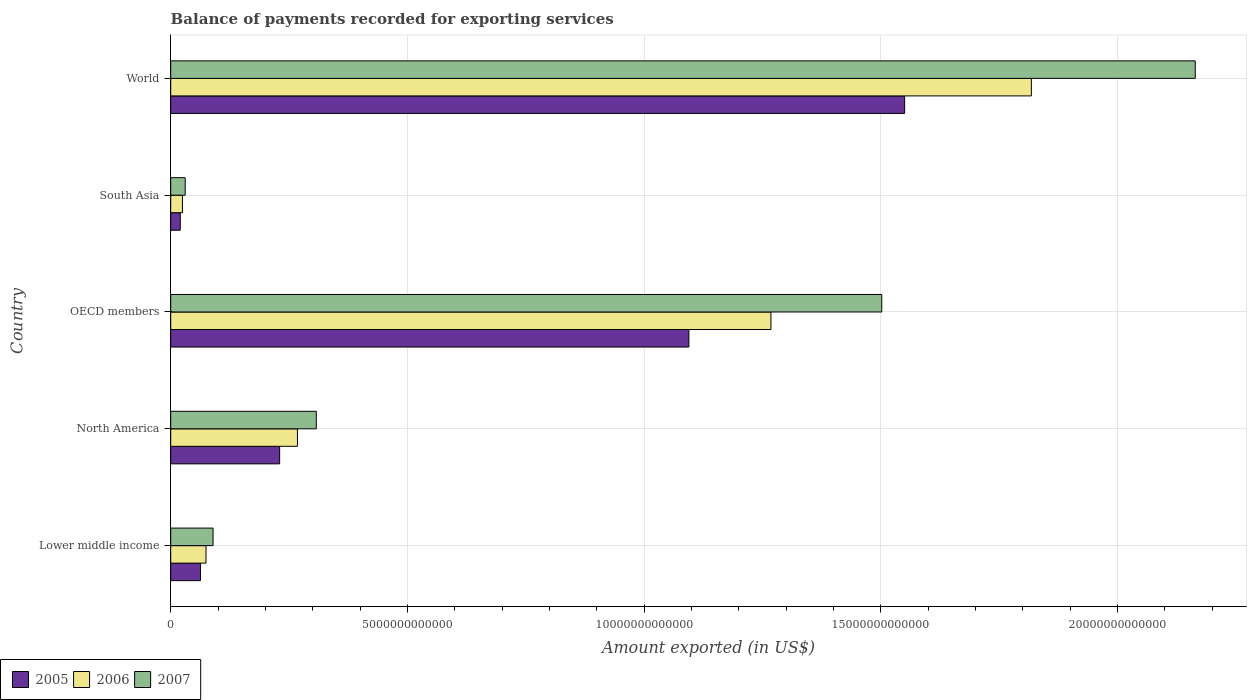Are the number of bars on each tick of the Y-axis equal?
Keep it short and to the point. Yes. How many bars are there on the 1st tick from the bottom?
Offer a very short reply. 3. What is the label of the 5th group of bars from the top?
Provide a succinct answer. Lower middle income. What is the amount exported in 2005 in North America?
Your answer should be very brief. 2.30e+12. Across all countries, what is the maximum amount exported in 2007?
Keep it short and to the point. 2.16e+13. Across all countries, what is the minimum amount exported in 2007?
Your answer should be compact. 3.06e+11. What is the total amount exported in 2006 in the graph?
Offer a terse response. 3.45e+13. What is the difference between the amount exported in 2005 in OECD members and that in South Asia?
Your answer should be compact. 1.07e+13. What is the difference between the amount exported in 2006 in Lower middle income and the amount exported in 2005 in South Asia?
Your response must be concise. 5.44e+11. What is the average amount exported in 2006 per country?
Keep it short and to the point. 6.91e+12. What is the difference between the amount exported in 2005 and amount exported in 2006 in OECD members?
Offer a very short reply. -1.73e+12. What is the ratio of the amount exported in 2006 in North America to that in World?
Your response must be concise. 0.15. Is the difference between the amount exported in 2005 in North America and OECD members greater than the difference between the amount exported in 2006 in North America and OECD members?
Provide a succinct answer. Yes. What is the difference between the highest and the second highest amount exported in 2007?
Offer a terse response. 6.62e+12. What is the difference between the highest and the lowest amount exported in 2005?
Give a very brief answer. 1.53e+13. Is the sum of the amount exported in 2005 in OECD members and World greater than the maximum amount exported in 2007 across all countries?
Ensure brevity in your answer.  Yes. What does the 2nd bar from the top in World represents?
Provide a succinct answer. 2006. What does the 2nd bar from the bottom in South Asia represents?
Keep it short and to the point. 2006. Is it the case that in every country, the sum of the amount exported in 2005 and amount exported in 2006 is greater than the amount exported in 2007?
Give a very brief answer. Yes. How many bars are there?
Provide a succinct answer. 15. Are all the bars in the graph horizontal?
Your answer should be compact. Yes. How many countries are there in the graph?
Provide a succinct answer. 5. What is the difference between two consecutive major ticks on the X-axis?
Provide a succinct answer. 5.00e+12. Are the values on the major ticks of X-axis written in scientific E-notation?
Provide a short and direct response. No. Does the graph contain grids?
Your answer should be very brief. Yes. What is the title of the graph?
Provide a short and direct response. Balance of payments recorded for exporting services. What is the label or title of the X-axis?
Your answer should be very brief. Amount exported (in US$). What is the label or title of the Y-axis?
Give a very brief answer. Country. What is the Amount exported (in US$) of 2005 in Lower middle income?
Provide a short and direct response. 6.29e+11. What is the Amount exported (in US$) in 2006 in Lower middle income?
Give a very brief answer. 7.46e+11. What is the Amount exported (in US$) of 2007 in Lower middle income?
Keep it short and to the point. 8.95e+11. What is the Amount exported (in US$) in 2005 in North America?
Make the answer very short. 2.30e+12. What is the Amount exported (in US$) of 2006 in North America?
Provide a succinct answer. 2.68e+12. What is the Amount exported (in US$) in 2007 in North America?
Provide a short and direct response. 3.08e+12. What is the Amount exported (in US$) of 2005 in OECD members?
Keep it short and to the point. 1.09e+13. What is the Amount exported (in US$) of 2006 in OECD members?
Your response must be concise. 1.27e+13. What is the Amount exported (in US$) in 2007 in OECD members?
Make the answer very short. 1.50e+13. What is the Amount exported (in US$) in 2005 in South Asia?
Give a very brief answer. 2.02e+11. What is the Amount exported (in US$) in 2006 in South Asia?
Offer a terse response. 2.48e+11. What is the Amount exported (in US$) in 2007 in South Asia?
Give a very brief answer. 3.06e+11. What is the Amount exported (in US$) in 2005 in World?
Give a very brief answer. 1.55e+13. What is the Amount exported (in US$) of 2006 in World?
Provide a succinct answer. 1.82e+13. What is the Amount exported (in US$) in 2007 in World?
Ensure brevity in your answer.  2.16e+13. Across all countries, what is the maximum Amount exported (in US$) in 2005?
Provide a short and direct response. 1.55e+13. Across all countries, what is the maximum Amount exported (in US$) in 2006?
Your answer should be compact. 1.82e+13. Across all countries, what is the maximum Amount exported (in US$) in 2007?
Ensure brevity in your answer.  2.16e+13. Across all countries, what is the minimum Amount exported (in US$) of 2005?
Your response must be concise. 2.02e+11. Across all countries, what is the minimum Amount exported (in US$) in 2006?
Your response must be concise. 2.48e+11. Across all countries, what is the minimum Amount exported (in US$) in 2007?
Provide a short and direct response. 3.06e+11. What is the total Amount exported (in US$) of 2005 in the graph?
Provide a short and direct response. 2.96e+13. What is the total Amount exported (in US$) in 2006 in the graph?
Provide a succinct answer. 3.45e+13. What is the total Amount exported (in US$) of 2007 in the graph?
Ensure brevity in your answer.  4.09e+13. What is the difference between the Amount exported (in US$) of 2005 in Lower middle income and that in North America?
Provide a succinct answer. -1.67e+12. What is the difference between the Amount exported (in US$) in 2006 in Lower middle income and that in North America?
Offer a terse response. -1.93e+12. What is the difference between the Amount exported (in US$) in 2007 in Lower middle income and that in North America?
Your answer should be very brief. -2.18e+12. What is the difference between the Amount exported (in US$) in 2005 in Lower middle income and that in OECD members?
Offer a terse response. -1.03e+13. What is the difference between the Amount exported (in US$) in 2006 in Lower middle income and that in OECD members?
Provide a short and direct response. -1.19e+13. What is the difference between the Amount exported (in US$) in 2007 in Lower middle income and that in OECD members?
Your answer should be compact. -1.41e+13. What is the difference between the Amount exported (in US$) in 2005 in Lower middle income and that in South Asia?
Give a very brief answer. 4.27e+11. What is the difference between the Amount exported (in US$) of 2006 in Lower middle income and that in South Asia?
Provide a succinct answer. 4.98e+11. What is the difference between the Amount exported (in US$) in 2007 in Lower middle income and that in South Asia?
Your answer should be very brief. 5.89e+11. What is the difference between the Amount exported (in US$) in 2005 in Lower middle income and that in World?
Offer a terse response. -1.49e+13. What is the difference between the Amount exported (in US$) in 2006 in Lower middle income and that in World?
Ensure brevity in your answer.  -1.74e+13. What is the difference between the Amount exported (in US$) in 2007 in Lower middle income and that in World?
Keep it short and to the point. -2.08e+13. What is the difference between the Amount exported (in US$) in 2005 in North America and that in OECD members?
Provide a succinct answer. -8.65e+12. What is the difference between the Amount exported (in US$) in 2006 in North America and that in OECD members?
Give a very brief answer. -1.00e+13. What is the difference between the Amount exported (in US$) of 2007 in North America and that in OECD members?
Offer a very short reply. -1.19e+13. What is the difference between the Amount exported (in US$) in 2005 in North America and that in South Asia?
Your answer should be very brief. 2.10e+12. What is the difference between the Amount exported (in US$) in 2006 in North America and that in South Asia?
Keep it short and to the point. 2.43e+12. What is the difference between the Amount exported (in US$) in 2007 in North America and that in South Asia?
Make the answer very short. 2.77e+12. What is the difference between the Amount exported (in US$) in 2005 in North America and that in World?
Keep it short and to the point. -1.32e+13. What is the difference between the Amount exported (in US$) of 2006 in North America and that in World?
Give a very brief answer. -1.55e+13. What is the difference between the Amount exported (in US$) in 2007 in North America and that in World?
Your answer should be very brief. -1.86e+13. What is the difference between the Amount exported (in US$) in 2005 in OECD members and that in South Asia?
Your answer should be compact. 1.07e+13. What is the difference between the Amount exported (in US$) in 2006 in OECD members and that in South Asia?
Provide a short and direct response. 1.24e+13. What is the difference between the Amount exported (in US$) of 2007 in OECD members and that in South Asia?
Your answer should be very brief. 1.47e+13. What is the difference between the Amount exported (in US$) in 2005 in OECD members and that in World?
Ensure brevity in your answer.  -4.56e+12. What is the difference between the Amount exported (in US$) in 2006 in OECD members and that in World?
Keep it short and to the point. -5.50e+12. What is the difference between the Amount exported (in US$) of 2007 in OECD members and that in World?
Your response must be concise. -6.62e+12. What is the difference between the Amount exported (in US$) of 2005 in South Asia and that in World?
Make the answer very short. -1.53e+13. What is the difference between the Amount exported (in US$) in 2006 in South Asia and that in World?
Provide a succinct answer. -1.79e+13. What is the difference between the Amount exported (in US$) of 2007 in South Asia and that in World?
Provide a short and direct response. -2.13e+13. What is the difference between the Amount exported (in US$) of 2005 in Lower middle income and the Amount exported (in US$) of 2006 in North America?
Offer a very short reply. -2.05e+12. What is the difference between the Amount exported (in US$) in 2005 in Lower middle income and the Amount exported (in US$) in 2007 in North America?
Your response must be concise. -2.45e+12. What is the difference between the Amount exported (in US$) in 2006 in Lower middle income and the Amount exported (in US$) in 2007 in North America?
Make the answer very short. -2.33e+12. What is the difference between the Amount exported (in US$) in 2005 in Lower middle income and the Amount exported (in US$) in 2006 in OECD members?
Offer a very short reply. -1.21e+13. What is the difference between the Amount exported (in US$) of 2005 in Lower middle income and the Amount exported (in US$) of 2007 in OECD members?
Give a very brief answer. -1.44e+13. What is the difference between the Amount exported (in US$) of 2006 in Lower middle income and the Amount exported (in US$) of 2007 in OECD members?
Provide a succinct answer. -1.43e+13. What is the difference between the Amount exported (in US$) of 2005 in Lower middle income and the Amount exported (in US$) of 2006 in South Asia?
Your response must be concise. 3.81e+11. What is the difference between the Amount exported (in US$) in 2005 in Lower middle income and the Amount exported (in US$) in 2007 in South Asia?
Keep it short and to the point. 3.23e+11. What is the difference between the Amount exported (in US$) of 2006 in Lower middle income and the Amount exported (in US$) of 2007 in South Asia?
Offer a terse response. 4.40e+11. What is the difference between the Amount exported (in US$) of 2005 in Lower middle income and the Amount exported (in US$) of 2006 in World?
Provide a succinct answer. -1.76e+13. What is the difference between the Amount exported (in US$) in 2005 in Lower middle income and the Amount exported (in US$) in 2007 in World?
Keep it short and to the point. -2.10e+13. What is the difference between the Amount exported (in US$) in 2006 in Lower middle income and the Amount exported (in US$) in 2007 in World?
Offer a very short reply. -2.09e+13. What is the difference between the Amount exported (in US$) of 2005 in North America and the Amount exported (in US$) of 2006 in OECD members?
Make the answer very short. -1.04e+13. What is the difference between the Amount exported (in US$) in 2005 in North America and the Amount exported (in US$) in 2007 in OECD members?
Provide a succinct answer. -1.27e+13. What is the difference between the Amount exported (in US$) in 2006 in North America and the Amount exported (in US$) in 2007 in OECD members?
Make the answer very short. -1.23e+13. What is the difference between the Amount exported (in US$) of 2005 in North America and the Amount exported (in US$) of 2006 in South Asia?
Your response must be concise. 2.05e+12. What is the difference between the Amount exported (in US$) in 2005 in North America and the Amount exported (in US$) in 2007 in South Asia?
Keep it short and to the point. 2.00e+12. What is the difference between the Amount exported (in US$) of 2006 in North America and the Amount exported (in US$) of 2007 in South Asia?
Your answer should be compact. 2.37e+12. What is the difference between the Amount exported (in US$) of 2005 in North America and the Amount exported (in US$) of 2006 in World?
Make the answer very short. -1.59e+13. What is the difference between the Amount exported (in US$) in 2005 in North America and the Amount exported (in US$) in 2007 in World?
Ensure brevity in your answer.  -1.93e+13. What is the difference between the Amount exported (in US$) in 2006 in North America and the Amount exported (in US$) in 2007 in World?
Provide a short and direct response. -1.90e+13. What is the difference between the Amount exported (in US$) in 2005 in OECD members and the Amount exported (in US$) in 2006 in South Asia?
Offer a terse response. 1.07e+13. What is the difference between the Amount exported (in US$) of 2005 in OECD members and the Amount exported (in US$) of 2007 in South Asia?
Your answer should be compact. 1.06e+13. What is the difference between the Amount exported (in US$) in 2006 in OECD members and the Amount exported (in US$) in 2007 in South Asia?
Keep it short and to the point. 1.24e+13. What is the difference between the Amount exported (in US$) in 2005 in OECD members and the Amount exported (in US$) in 2006 in World?
Ensure brevity in your answer.  -7.24e+12. What is the difference between the Amount exported (in US$) of 2005 in OECD members and the Amount exported (in US$) of 2007 in World?
Provide a short and direct response. -1.07e+13. What is the difference between the Amount exported (in US$) of 2006 in OECD members and the Amount exported (in US$) of 2007 in World?
Offer a very short reply. -8.96e+12. What is the difference between the Amount exported (in US$) of 2005 in South Asia and the Amount exported (in US$) of 2006 in World?
Your answer should be very brief. -1.80e+13. What is the difference between the Amount exported (in US$) in 2005 in South Asia and the Amount exported (in US$) in 2007 in World?
Make the answer very short. -2.14e+13. What is the difference between the Amount exported (in US$) in 2006 in South Asia and the Amount exported (in US$) in 2007 in World?
Make the answer very short. -2.14e+13. What is the average Amount exported (in US$) in 2005 per country?
Keep it short and to the point. 5.92e+12. What is the average Amount exported (in US$) of 2006 per country?
Ensure brevity in your answer.  6.91e+12. What is the average Amount exported (in US$) of 2007 per country?
Your answer should be very brief. 8.19e+12. What is the difference between the Amount exported (in US$) of 2005 and Amount exported (in US$) of 2006 in Lower middle income?
Keep it short and to the point. -1.17e+11. What is the difference between the Amount exported (in US$) of 2005 and Amount exported (in US$) of 2007 in Lower middle income?
Your answer should be compact. -2.66e+11. What is the difference between the Amount exported (in US$) of 2006 and Amount exported (in US$) of 2007 in Lower middle income?
Provide a short and direct response. -1.49e+11. What is the difference between the Amount exported (in US$) in 2005 and Amount exported (in US$) in 2006 in North America?
Keep it short and to the point. -3.76e+11. What is the difference between the Amount exported (in US$) of 2005 and Amount exported (in US$) of 2007 in North America?
Provide a succinct answer. -7.74e+11. What is the difference between the Amount exported (in US$) of 2006 and Amount exported (in US$) of 2007 in North America?
Offer a very short reply. -3.98e+11. What is the difference between the Amount exported (in US$) in 2005 and Amount exported (in US$) in 2006 in OECD members?
Make the answer very short. -1.73e+12. What is the difference between the Amount exported (in US$) of 2005 and Amount exported (in US$) of 2007 in OECD members?
Make the answer very short. -4.07e+12. What is the difference between the Amount exported (in US$) of 2006 and Amount exported (in US$) of 2007 in OECD members?
Your answer should be compact. -2.34e+12. What is the difference between the Amount exported (in US$) of 2005 and Amount exported (in US$) of 2006 in South Asia?
Make the answer very short. -4.61e+1. What is the difference between the Amount exported (in US$) in 2005 and Amount exported (in US$) in 2007 in South Asia?
Offer a terse response. -1.04e+11. What is the difference between the Amount exported (in US$) of 2006 and Amount exported (in US$) of 2007 in South Asia?
Offer a terse response. -5.78e+1. What is the difference between the Amount exported (in US$) in 2005 and Amount exported (in US$) in 2006 in World?
Provide a short and direct response. -2.68e+12. What is the difference between the Amount exported (in US$) of 2005 and Amount exported (in US$) of 2007 in World?
Keep it short and to the point. -6.14e+12. What is the difference between the Amount exported (in US$) of 2006 and Amount exported (in US$) of 2007 in World?
Your answer should be very brief. -3.46e+12. What is the ratio of the Amount exported (in US$) of 2005 in Lower middle income to that in North America?
Provide a short and direct response. 0.27. What is the ratio of the Amount exported (in US$) of 2006 in Lower middle income to that in North America?
Offer a terse response. 0.28. What is the ratio of the Amount exported (in US$) in 2007 in Lower middle income to that in North America?
Give a very brief answer. 0.29. What is the ratio of the Amount exported (in US$) in 2005 in Lower middle income to that in OECD members?
Keep it short and to the point. 0.06. What is the ratio of the Amount exported (in US$) in 2006 in Lower middle income to that in OECD members?
Your answer should be compact. 0.06. What is the ratio of the Amount exported (in US$) in 2007 in Lower middle income to that in OECD members?
Your answer should be compact. 0.06. What is the ratio of the Amount exported (in US$) in 2005 in Lower middle income to that in South Asia?
Your answer should be very brief. 3.11. What is the ratio of the Amount exported (in US$) of 2006 in Lower middle income to that in South Asia?
Keep it short and to the point. 3.01. What is the ratio of the Amount exported (in US$) of 2007 in Lower middle income to that in South Asia?
Offer a terse response. 2.92. What is the ratio of the Amount exported (in US$) of 2005 in Lower middle income to that in World?
Offer a very short reply. 0.04. What is the ratio of the Amount exported (in US$) of 2006 in Lower middle income to that in World?
Your response must be concise. 0.04. What is the ratio of the Amount exported (in US$) in 2007 in Lower middle income to that in World?
Your answer should be very brief. 0.04. What is the ratio of the Amount exported (in US$) of 2005 in North America to that in OECD members?
Your answer should be very brief. 0.21. What is the ratio of the Amount exported (in US$) of 2006 in North America to that in OECD members?
Offer a very short reply. 0.21. What is the ratio of the Amount exported (in US$) in 2007 in North America to that in OECD members?
Your answer should be compact. 0.2. What is the ratio of the Amount exported (in US$) of 2005 in North America to that in South Asia?
Offer a very short reply. 11.38. What is the ratio of the Amount exported (in US$) of 2006 in North America to that in South Asia?
Make the answer very short. 10.79. What is the ratio of the Amount exported (in US$) in 2007 in North America to that in South Asia?
Give a very brief answer. 10.05. What is the ratio of the Amount exported (in US$) in 2005 in North America to that in World?
Make the answer very short. 0.15. What is the ratio of the Amount exported (in US$) of 2006 in North America to that in World?
Provide a short and direct response. 0.15. What is the ratio of the Amount exported (in US$) in 2007 in North America to that in World?
Your answer should be very brief. 0.14. What is the ratio of the Amount exported (in US$) of 2005 in OECD members to that in South Asia?
Keep it short and to the point. 54.15. What is the ratio of the Amount exported (in US$) of 2006 in OECD members to that in South Asia?
Your answer should be compact. 51.07. What is the ratio of the Amount exported (in US$) of 2007 in OECD members to that in South Asia?
Your answer should be very brief. 49.07. What is the ratio of the Amount exported (in US$) of 2005 in OECD members to that in World?
Your response must be concise. 0.71. What is the ratio of the Amount exported (in US$) of 2006 in OECD members to that in World?
Offer a very short reply. 0.7. What is the ratio of the Amount exported (in US$) in 2007 in OECD members to that in World?
Your answer should be very brief. 0.69. What is the ratio of the Amount exported (in US$) in 2005 in South Asia to that in World?
Give a very brief answer. 0.01. What is the ratio of the Amount exported (in US$) of 2006 in South Asia to that in World?
Give a very brief answer. 0.01. What is the ratio of the Amount exported (in US$) of 2007 in South Asia to that in World?
Offer a terse response. 0.01. What is the difference between the highest and the second highest Amount exported (in US$) of 2005?
Provide a short and direct response. 4.56e+12. What is the difference between the highest and the second highest Amount exported (in US$) in 2006?
Your answer should be very brief. 5.50e+12. What is the difference between the highest and the second highest Amount exported (in US$) of 2007?
Keep it short and to the point. 6.62e+12. What is the difference between the highest and the lowest Amount exported (in US$) of 2005?
Ensure brevity in your answer.  1.53e+13. What is the difference between the highest and the lowest Amount exported (in US$) of 2006?
Your answer should be very brief. 1.79e+13. What is the difference between the highest and the lowest Amount exported (in US$) of 2007?
Your answer should be very brief. 2.13e+13. 